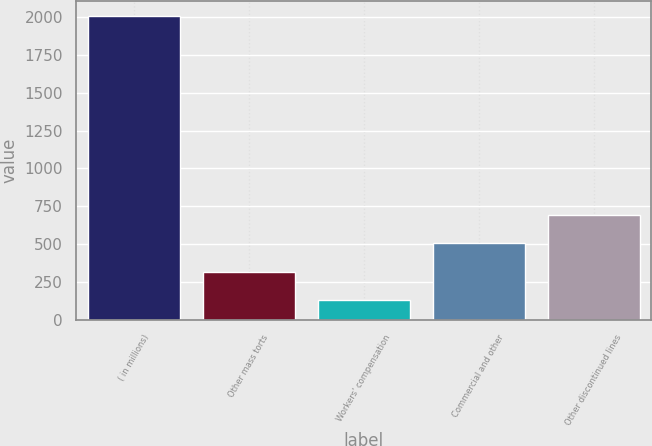Convert chart to OTSL. <chart><loc_0><loc_0><loc_500><loc_500><bar_chart><fcel>( in millions)<fcel>Other mass torts<fcel>Workers' compensation<fcel>Commercial and other<fcel>Other discontinued lines<nl><fcel>2008<fcel>317.8<fcel>130<fcel>505.6<fcel>693.4<nl></chart> 